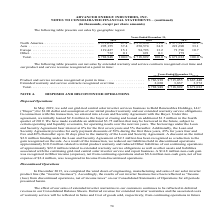According to Advanced Energy's financial document, What was the Product and service revenue recognized at point in time in 2019? According to the financial document, $786,918 (in thousands). The relevant text states: "d service revenue recognized at point in time . $ 786,918 $ 715,055 $ 667,440 Extended warranty and service contracts recognized over time . 2,030 3,837 3,57..." Also, What was the Extended warranty and service contracts recognized over time in 2018? According to the financial document, 3,837 (in thousands). The relevant text states: "nd service contracts recognized over time . 2,030 3,837 3,572 Total . $ 788,948 $ 718,892 $ 671,012..." Also, What does the table represent? net sales by extended warranty and service contracts recognized over time and our product and service revenue recognized at a point in time. The document states: "The following table presents our net sales by extended warranty and service contracts recognized over time and our product and service revenue recogni..." Also, can you calculate: What was the change in Product and service revenue recognized at point in time between 2018 and 2019? Based on the calculation: $786,918-$715,055, the result is 71863 (in thousands). This is based on the information: "revenue recognized at point in time . $ 786,918 $ 715,055 $ 667,440 Extended warranty and service contracts recognized over time . 2,030 3,837 3,572 Total . d service revenue recognized at point in ti..." The key data points involved are: 715,055, 786,918. Also, can you calculate: What was the change in Extended warranty and service contracts recognized over time between 2017 and 2018? Based on the calculation: 3,837-3,572, the result is 265 (in thousands). This is based on the information: "vice contracts recognized over time . 2,030 3,837 3,572 Total . $ 788,948 $ 718,892 $ 671,012 nd service contracts recognized over time . 2,030 3,837 3,572 Total . $ 788,948 $ 718,892 $ 671,012..." The key data points involved are: 3,572, 3,837. Also, can you calculate: What was the percentage change in total net sales between 2018 and 2019? To answer this question, I need to perform calculations using the financial data. The calculation is: ($788,948-$718,892)/$718,892, which equals 9.74 (percentage). This is based on the information: ",796 10.7 Other . 732 0.1 691 0.1 179 — Total . $ 788,948 100.0 % $ 718,892 100.0 % $ 671,012 100.0 % 732 0.1 691 0.1 179 — Total . $ 788,948 100.0 % $ 718,892 100.0 % $ 671,012 100.0 %..." The key data points involved are: 718,892, 788,948. 